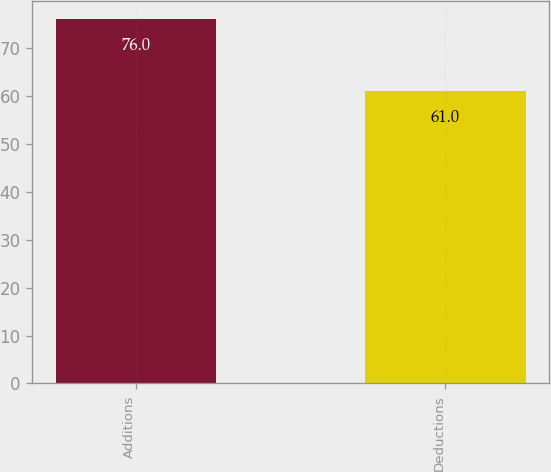<chart> <loc_0><loc_0><loc_500><loc_500><bar_chart><fcel>Additions<fcel>Deductions<nl><fcel>76<fcel>61<nl></chart> 